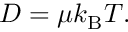<formula> <loc_0><loc_0><loc_500><loc_500>\begin{array} { r } { D = \mu k _ { B } T . } \end{array}</formula> 